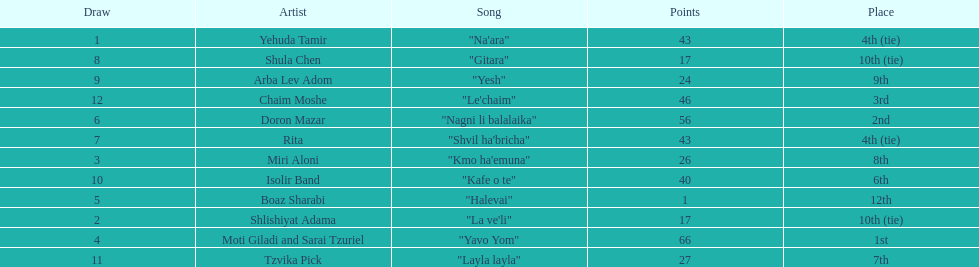What is the total amount of ties in this competition? 2. Could you parse the entire table as a dict? {'header': ['Draw', 'Artist', 'Song', 'Points', 'Place'], 'rows': [['1', 'Yehuda Tamir', '"Na\'ara"', '43', '4th (tie)'], ['8', 'Shula Chen', '"Gitara"', '17', '10th (tie)'], ['9', 'Arba Lev Adom', '"Yesh"', '24', '9th'], ['12', 'Chaim Moshe', '"Le\'chaim"', '46', '3rd'], ['6', 'Doron Mazar', '"Nagni li balalaika"', '56', '2nd'], ['7', 'Rita', '"Shvil ha\'bricha"', '43', '4th (tie)'], ['3', 'Miri Aloni', '"Kmo ha\'emuna"', '26', '8th'], ['10', 'Isolir Band', '"Kafe o te"', '40', '6th'], ['5', 'Boaz Sharabi', '"Halevai"', '1', '12th'], ['2', 'Shlishiyat Adama', '"La ve\'li"', '17', '10th (tie)'], ['4', 'Moti Giladi and Sarai Tzuriel', '"Yavo Yom"', '66', '1st'], ['11', 'Tzvika Pick', '"Layla layla"', '27', '7th']]} 